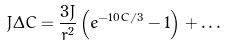<formula> <loc_0><loc_0><loc_500><loc_500>J \Delta C = \frac { 3 J } { r ^ { 2 } } \left ( e ^ { - 1 0 C / 3 } - 1 \right ) + \dots</formula> 